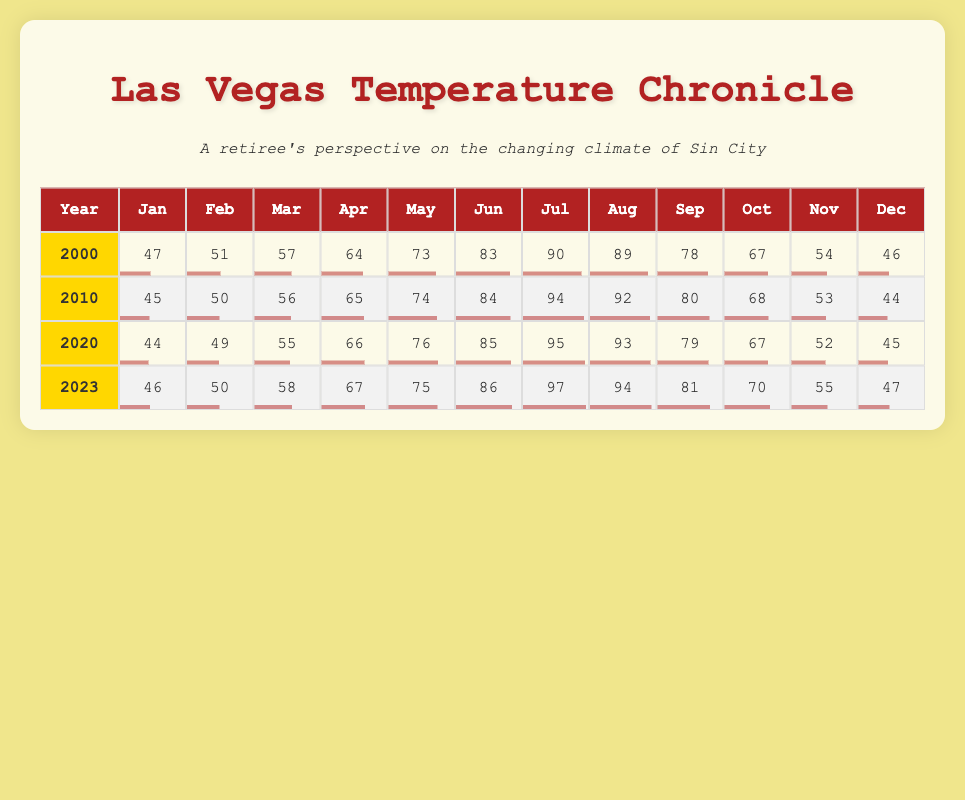What was the average temperature in Las Vegas in July for all years listed? To find the average July temperature from the table, first extract the temperatures: 90 (2000), 94 (2010), 95 (2020), and 97 (2023). Then, sum these values: 90 + 94 + 95 + 97 = 376. Since there are 4 years, divide by 4 to get the average: 376 / 4 = 94.
Answer: 94 Which month had the highest average temperature in 2020? From the table, look at the temperatures for 2020: January 44, February 49, March 55, April 66, May 76, June 85, July 95, August 93, September 79, October 67, November 52, December 45. The highest temperature is in July at 95.
Answer: July Was the average temperature in Las Vegas in January warmer in 2023 compared to 2010? Check the January temperatures: 46 (2023) and 45 (2010). Since 46 > 45, January 2023 was indeed warmer than January 2010.
Answer: Yes What is the difference in temperature between the hottest month and the coldest month for the year 2010? For 2010, the highest temperature is in July at 94 and the lowest is in January at 45. To find the difference, subtract the lowest from the highest: 94 - 45 = 49.
Answer: 49 How did the average temperature in March change from 2000 to 2023? Look at the March temperatures: 57 (2000) and 58 (2023). The change is found by subtracting the earlier value from the later: 58 - 57 = 1, indicating an increase.
Answer: Increased by 1 Which year had the coolest December temperature? The December temperatures are: 46 (2000), 44 (2010), 45 (2020), and 47 (2023). The lowest value is 44 from the year 2010, making it the coolest December.
Answer: 2010 What is the average temperature across all months for the year 2023? The monthly temperatures for 2023 are 46, 50, 58, 67, 75, 86, 97, 94, 81, 70, 55, and 47. Sum these values: 46 + 50 + 58 + 67 + 75 + 86 + 97 + 94 + 81 + 70 + 55 + 47 =  360. Since there are 12 months, divide by 12 to find the average: 360 / 12 = 70.
Answer: 70 Is the average temperature in June consistently above 80 degrees from 2000 to 2023? Check the June temperatures: 83 (2000), 84 (2010), 85 (2020), and 86 (2023). All these values are above 80, confirming that June has consistently had temperatures above 80 degrees during these years.
Answer: Yes 